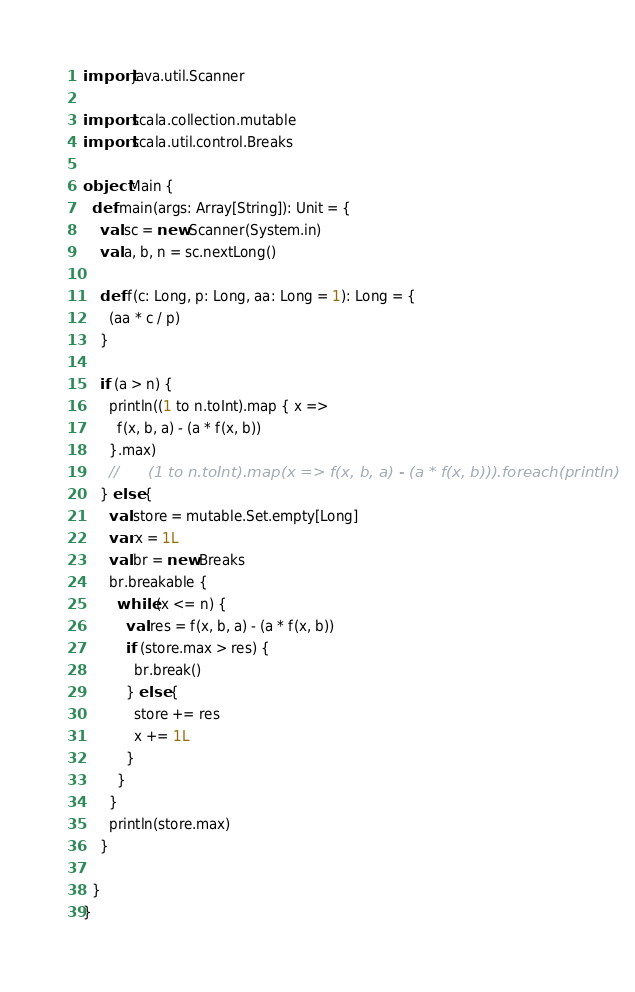Convert code to text. <code><loc_0><loc_0><loc_500><loc_500><_Scala_>import java.util.Scanner

import scala.collection.mutable
import scala.util.control.Breaks

object Main {
  def main(args: Array[String]): Unit = {
    val sc = new Scanner(System.in)
    val a, b, n = sc.nextLong()

    def f(c: Long, p: Long, aa: Long = 1): Long = {
      (aa * c / p)
    }

    if (a > n) {
      println((1 to n.toInt).map { x =>
        f(x, b, a) - (a * f(x, b))
      }.max)
      //      (1 to n.toInt).map(x => f(x, b, a) - (a * f(x, b))).foreach(println)
    } else {
      val store = mutable.Set.empty[Long]
      var x = 1L
      val br = new Breaks
      br.breakable {
        while (x <= n) {
          val res = f(x, b, a) - (a * f(x, b))
          if (store.max > res) {
            br.break()
          } else {
            store += res
            x += 1L
          }
        }
      }
      println(store.max)
    }

  }
}
</code> 